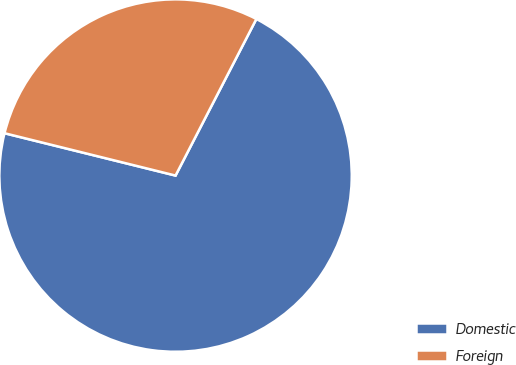Convert chart to OTSL. <chart><loc_0><loc_0><loc_500><loc_500><pie_chart><fcel>Domestic<fcel>Foreign<nl><fcel>71.28%<fcel>28.72%<nl></chart> 